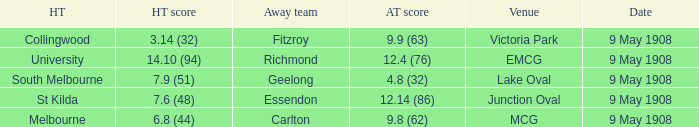Name the home team for carlton away team Melbourne. 